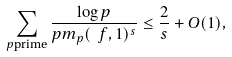<formula> <loc_0><loc_0><loc_500><loc_500>\sum _ { p \text {prime} } \frac { \log p } { p m _ { p } ( \ f , 1 ) ^ { s } } \leq \frac { 2 } { s } + O ( 1 ) ,</formula> 